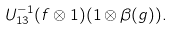<formula> <loc_0><loc_0><loc_500><loc_500>U ^ { - 1 } _ { 1 3 } ( f \otimes 1 ) ( 1 \otimes \beta ( g ) ) .</formula> 